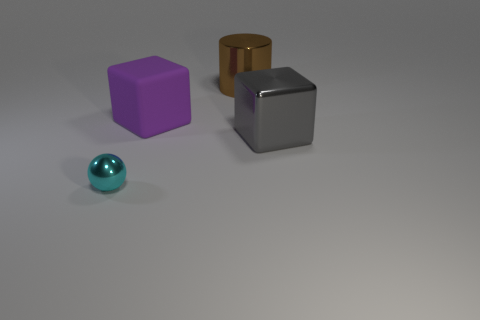What is the material of the small object?
Make the answer very short. Metal. Does the shiny object on the right side of the brown metallic thing have the same size as the sphere?
Your answer should be compact. No. There is a metallic object that is on the right side of the cylinder; what size is it?
Your answer should be very brief. Large. Are there any other things that have the same material as the purple thing?
Keep it short and to the point. No. How many big yellow shiny blocks are there?
Your response must be concise. 0. The metallic thing that is both in front of the brown shiny cylinder and on the right side of the purple matte block is what color?
Provide a succinct answer. Gray. Are there any cyan metallic things left of the big shiny cube?
Ensure brevity in your answer.  Yes. There is a cube that is right of the metal cylinder; how many cubes are on the left side of it?
Ensure brevity in your answer.  1. What size is the cyan thing that is made of the same material as the gray object?
Make the answer very short. Small. What is the size of the cyan ball?
Your response must be concise. Small. 